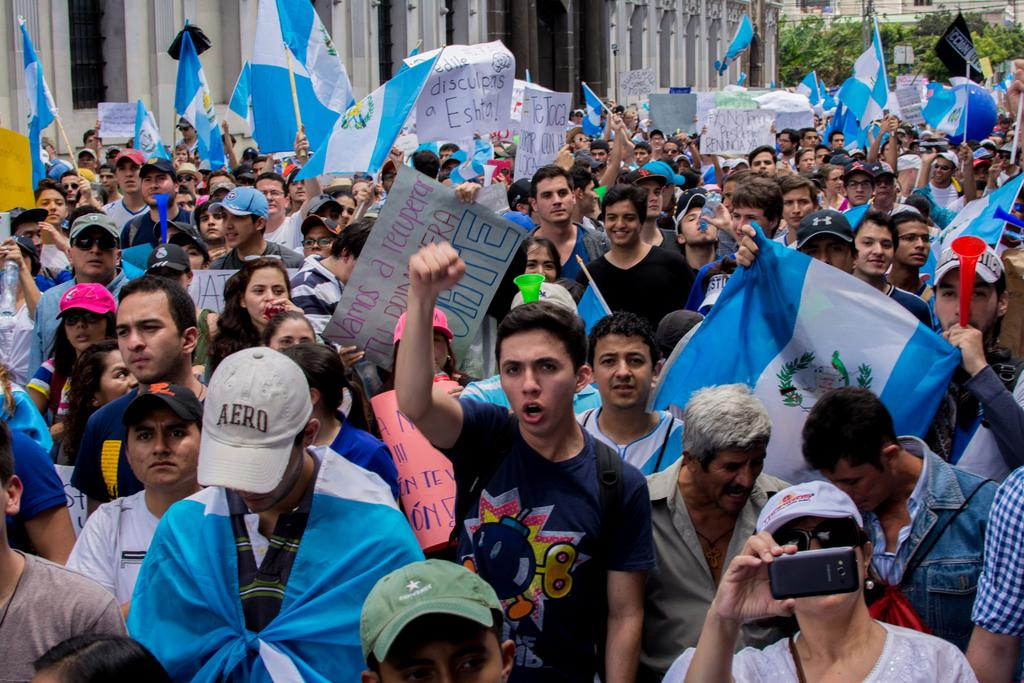How many people are present in the image? There are people in the image, but the exact number is not specified. What are some of the people holding in the image? Some people are holding poles, flags, posters, and mobile phones in the image. What can be seen in the background of the image? There are buildings and trees in the image. What type of flowers can be seen growing on the mountain in the image? There is no mountain or flowers present in the image. How many people are part of the crowd in the image? There is no crowd mentioned in the image; it only states that there are people present. 